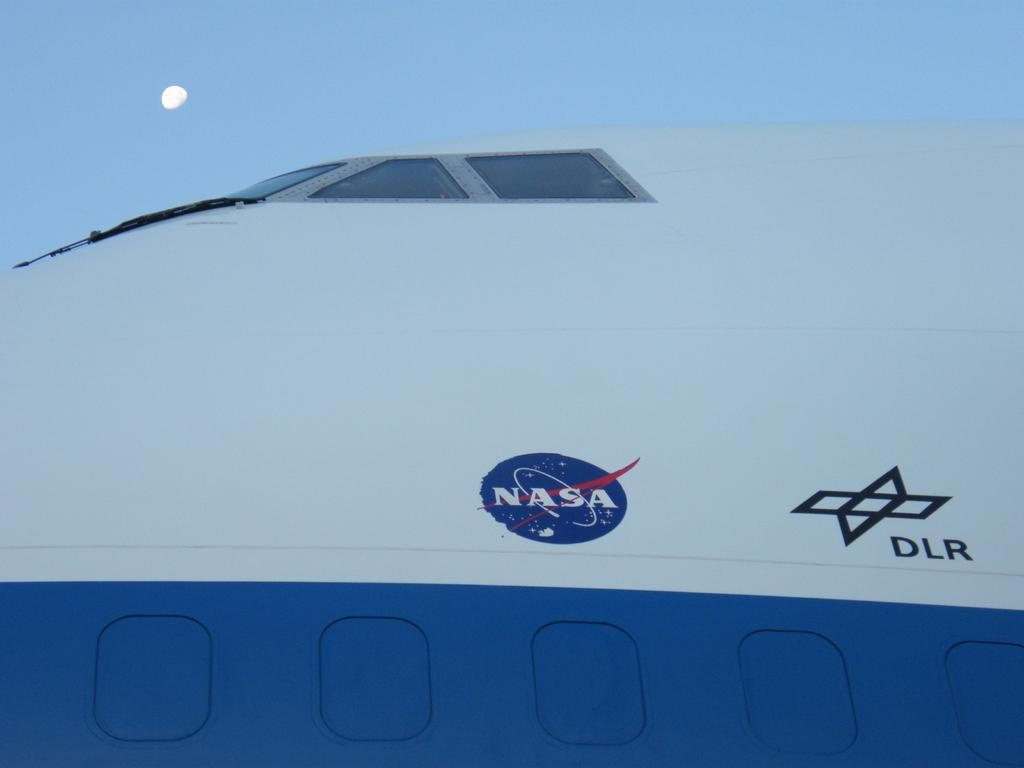<image>
Give a short and clear explanation of the subsequent image. A large NASA spaceship is big compared to the moon in the background. 